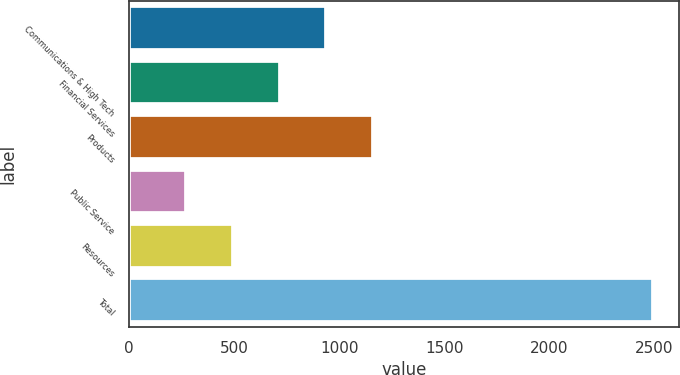Convert chart to OTSL. <chart><loc_0><loc_0><loc_500><loc_500><bar_chart><fcel>Communications & High Tech<fcel>Financial Services<fcel>Products<fcel>Public Service<fcel>Resources<fcel>Total<nl><fcel>938.3<fcel>716.2<fcel>1160.4<fcel>272<fcel>494.1<fcel>2493<nl></chart> 